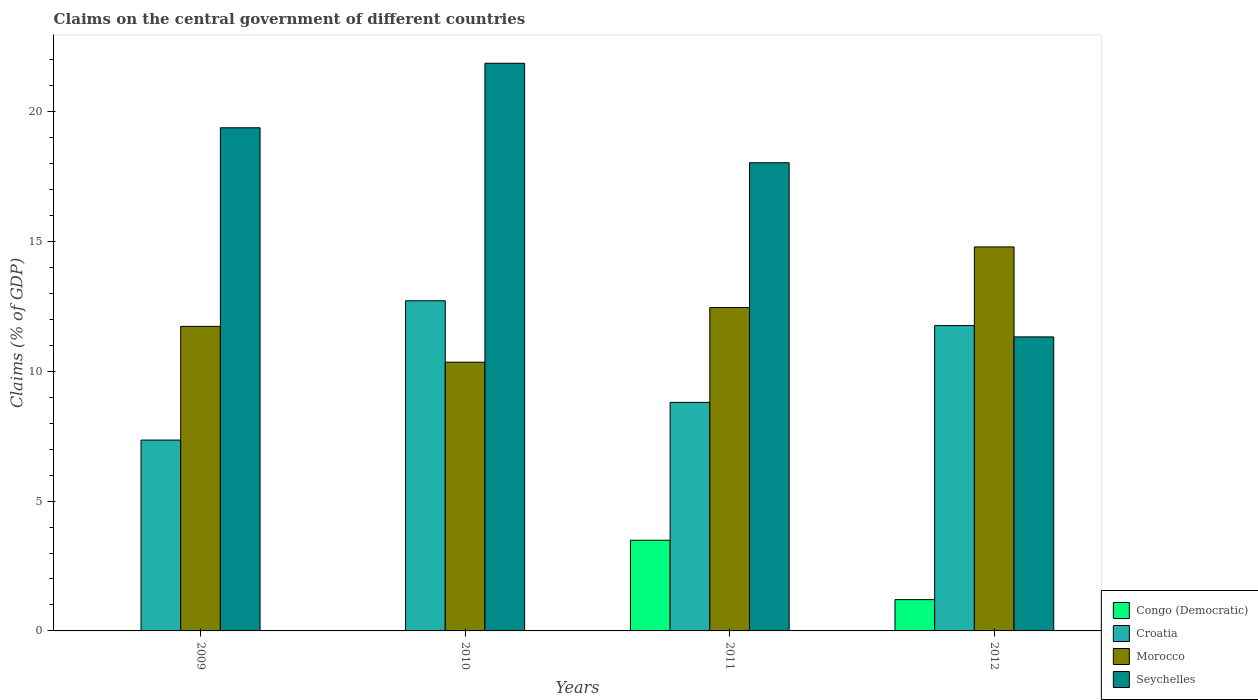Are the number of bars per tick equal to the number of legend labels?
Your response must be concise. No. Are the number of bars on each tick of the X-axis equal?
Your response must be concise. No. In how many cases, is the number of bars for a given year not equal to the number of legend labels?
Offer a very short reply. 2. What is the percentage of GDP claimed on the central government in Morocco in 2010?
Offer a terse response. 10.35. Across all years, what is the maximum percentage of GDP claimed on the central government in Seychelles?
Provide a succinct answer. 21.87. Across all years, what is the minimum percentage of GDP claimed on the central government in Morocco?
Ensure brevity in your answer.  10.35. What is the total percentage of GDP claimed on the central government in Morocco in the graph?
Offer a very short reply. 49.33. What is the difference between the percentage of GDP claimed on the central government in Seychelles in 2010 and that in 2012?
Your answer should be very brief. 10.54. What is the difference between the percentage of GDP claimed on the central government in Morocco in 2011 and the percentage of GDP claimed on the central government in Seychelles in 2010?
Keep it short and to the point. -9.41. What is the average percentage of GDP claimed on the central government in Morocco per year?
Your answer should be very brief. 12.33. In the year 2011, what is the difference between the percentage of GDP claimed on the central government in Morocco and percentage of GDP claimed on the central government in Congo (Democratic)?
Make the answer very short. 8.96. What is the ratio of the percentage of GDP claimed on the central government in Croatia in 2009 to that in 2010?
Ensure brevity in your answer.  0.58. Is the percentage of GDP claimed on the central government in Morocco in 2009 less than that in 2012?
Your response must be concise. Yes. Is the difference between the percentage of GDP claimed on the central government in Morocco in 2011 and 2012 greater than the difference between the percentage of GDP claimed on the central government in Congo (Democratic) in 2011 and 2012?
Provide a succinct answer. No. What is the difference between the highest and the second highest percentage of GDP claimed on the central government in Croatia?
Your response must be concise. 0.95. What is the difference between the highest and the lowest percentage of GDP claimed on the central government in Seychelles?
Keep it short and to the point. 10.54. In how many years, is the percentage of GDP claimed on the central government in Congo (Democratic) greater than the average percentage of GDP claimed on the central government in Congo (Democratic) taken over all years?
Provide a succinct answer. 2. Is the sum of the percentage of GDP claimed on the central government in Seychelles in 2009 and 2011 greater than the maximum percentage of GDP claimed on the central government in Morocco across all years?
Your answer should be compact. Yes. Is it the case that in every year, the sum of the percentage of GDP claimed on the central government in Congo (Democratic) and percentage of GDP claimed on the central government in Croatia is greater than the sum of percentage of GDP claimed on the central government in Morocco and percentage of GDP claimed on the central government in Seychelles?
Give a very brief answer. Yes. How many bars are there?
Keep it short and to the point. 14. Are all the bars in the graph horizontal?
Offer a very short reply. No. How many years are there in the graph?
Give a very brief answer. 4. Are the values on the major ticks of Y-axis written in scientific E-notation?
Make the answer very short. No. Does the graph contain any zero values?
Provide a succinct answer. Yes. Where does the legend appear in the graph?
Provide a succinct answer. Bottom right. What is the title of the graph?
Your answer should be compact. Claims on the central government of different countries. Does "Faeroe Islands" appear as one of the legend labels in the graph?
Your response must be concise. No. What is the label or title of the Y-axis?
Give a very brief answer. Claims (% of GDP). What is the Claims (% of GDP) in Congo (Democratic) in 2009?
Make the answer very short. 0. What is the Claims (% of GDP) in Croatia in 2009?
Offer a terse response. 7.35. What is the Claims (% of GDP) in Morocco in 2009?
Ensure brevity in your answer.  11.73. What is the Claims (% of GDP) of Seychelles in 2009?
Keep it short and to the point. 19.38. What is the Claims (% of GDP) of Congo (Democratic) in 2010?
Offer a terse response. 0. What is the Claims (% of GDP) of Croatia in 2010?
Ensure brevity in your answer.  12.72. What is the Claims (% of GDP) in Morocco in 2010?
Your response must be concise. 10.35. What is the Claims (% of GDP) of Seychelles in 2010?
Provide a short and direct response. 21.87. What is the Claims (% of GDP) of Congo (Democratic) in 2011?
Keep it short and to the point. 3.49. What is the Claims (% of GDP) in Croatia in 2011?
Your answer should be very brief. 8.8. What is the Claims (% of GDP) of Morocco in 2011?
Your answer should be very brief. 12.46. What is the Claims (% of GDP) of Seychelles in 2011?
Your answer should be very brief. 18.03. What is the Claims (% of GDP) in Congo (Democratic) in 2012?
Your answer should be very brief. 1.2. What is the Claims (% of GDP) of Croatia in 2012?
Provide a short and direct response. 11.76. What is the Claims (% of GDP) in Morocco in 2012?
Offer a very short reply. 14.79. What is the Claims (% of GDP) in Seychelles in 2012?
Provide a succinct answer. 11.33. Across all years, what is the maximum Claims (% of GDP) of Congo (Democratic)?
Your answer should be compact. 3.49. Across all years, what is the maximum Claims (% of GDP) in Croatia?
Provide a succinct answer. 12.72. Across all years, what is the maximum Claims (% of GDP) in Morocco?
Make the answer very short. 14.79. Across all years, what is the maximum Claims (% of GDP) of Seychelles?
Keep it short and to the point. 21.87. Across all years, what is the minimum Claims (% of GDP) in Croatia?
Provide a short and direct response. 7.35. Across all years, what is the minimum Claims (% of GDP) in Morocco?
Give a very brief answer. 10.35. Across all years, what is the minimum Claims (% of GDP) in Seychelles?
Offer a very short reply. 11.33. What is the total Claims (% of GDP) of Congo (Democratic) in the graph?
Your response must be concise. 4.7. What is the total Claims (% of GDP) of Croatia in the graph?
Offer a terse response. 40.63. What is the total Claims (% of GDP) of Morocco in the graph?
Provide a succinct answer. 49.33. What is the total Claims (% of GDP) of Seychelles in the graph?
Your answer should be very brief. 70.6. What is the difference between the Claims (% of GDP) in Croatia in 2009 and that in 2010?
Offer a very short reply. -5.37. What is the difference between the Claims (% of GDP) in Morocco in 2009 and that in 2010?
Make the answer very short. 1.38. What is the difference between the Claims (% of GDP) in Seychelles in 2009 and that in 2010?
Keep it short and to the point. -2.49. What is the difference between the Claims (% of GDP) of Croatia in 2009 and that in 2011?
Your response must be concise. -1.45. What is the difference between the Claims (% of GDP) of Morocco in 2009 and that in 2011?
Make the answer very short. -0.73. What is the difference between the Claims (% of GDP) in Seychelles in 2009 and that in 2011?
Make the answer very short. 1.35. What is the difference between the Claims (% of GDP) of Croatia in 2009 and that in 2012?
Offer a very short reply. -4.41. What is the difference between the Claims (% of GDP) of Morocco in 2009 and that in 2012?
Make the answer very short. -3.06. What is the difference between the Claims (% of GDP) in Seychelles in 2009 and that in 2012?
Provide a succinct answer. 8.06. What is the difference between the Claims (% of GDP) of Croatia in 2010 and that in 2011?
Your answer should be compact. 3.91. What is the difference between the Claims (% of GDP) in Morocco in 2010 and that in 2011?
Your answer should be very brief. -2.1. What is the difference between the Claims (% of GDP) of Seychelles in 2010 and that in 2011?
Your answer should be compact. 3.83. What is the difference between the Claims (% of GDP) of Croatia in 2010 and that in 2012?
Provide a succinct answer. 0.95. What is the difference between the Claims (% of GDP) in Morocco in 2010 and that in 2012?
Provide a short and direct response. -4.44. What is the difference between the Claims (% of GDP) in Seychelles in 2010 and that in 2012?
Keep it short and to the point. 10.54. What is the difference between the Claims (% of GDP) in Congo (Democratic) in 2011 and that in 2012?
Offer a terse response. 2.29. What is the difference between the Claims (% of GDP) of Croatia in 2011 and that in 2012?
Ensure brevity in your answer.  -2.96. What is the difference between the Claims (% of GDP) in Morocco in 2011 and that in 2012?
Offer a terse response. -2.33. What is the difference between the Claims (% of GDP) in Seychelles in 2011 and that in 2012?
Offer a very short reply. 6.71. What is the difference between the Claims (% of GDP) in Croatia in 2009 and the Claims (% of GDP) in Morocco in 2010?
Make the answer very short. -3. What is the difference between the Claims (% of GDP) of Croatia in 2009 and the Claims (% of GDP) of Seychelles in 2010?
Your answer should be compact. -14.51. What is the difference between the Claims (% of GDP) of Morocco in 2009 and the Claims (% of GDP) of Seychelles in 2010?
Offer a terse response. -10.14. What is the difference between the Claims (% of GDP) of Croatia in 2009 and the Claims (% of GDP) of Morocco in 2011?
Your answer should be very brief. -5.1. What is the difference between the Claims (% of GDP) of Croatia in 2009 and the Claims (% of GDP) of Seychelles in 2011?
Provide a short and direct response. -10.68. What is the difference between the Claims (% of GDP) of Morocco in 2009 and the Claims (% of GDP) of Seychelles in 2011?
Your response must be concise. -6.3. What is the difference between the Claims (% of GDP) of Croatia in 2009 and the Claims (% of GDP) of Morocco in 2012?
Offer a terse response. -7.44. What is the difference between the Claims (% of GDP) in Croatia in 2009 and the Claims (% of GDP) in Seychelles in 2012?
Give a very brief answer. -3.97. What is the difference between the Claims (% of GDP) in Morocco in 2009 and the Claims (% of GDP) in Seychelles in 2012?
Offer a very short reply. 0.4. What is the difference between the Claims (% of GDP) in Croatia in 2010 and the Claims (% of GDP) in Morocco in 2011?
Make the answer very short. 0.26. What is the difference between the Claims (% of GDP) in Croatia in 2010 and the Claims (% of GDP) in Seychelles in 2011?
Make the answer very short. -5.32. What is the difference between the Claims (% of GDP) of Morocco in 2010 and the Claims (% of GDP) of Seychelles in 2011?
Make the answer very short. -7.68. What is the difference between the Claims (% of GDP) in Croatia in 2010 and the Claims (% of GDP) in Morocco in 2012?
Keep it short and to the point. -2.07. What is the difference between the Claims (% of GDP) in Croatia in 2010 and the Claims (% of GDP) in Seychelles in 2012?
Provide a succinct answer. 1.39. What is the difference between the Claims (% of GDP) of Morocco in 2010 and the Claims (% of GDP) of Seychelles in 2012?
Your response must be concise. -0.97. What is the difference between the Claims (% of GDP) of Congo (Democratic) in 2011 and the Claims (% of GDP) of Croatia in 2012?
Your answer should be very brief. -8.27. What is the difference between the Claims (% of GDP) in Congo (Democratic) in 2011 and the Claims (% of GDP) in Morocco in 2012?
Make the answer very short. -11.3. What is the difference between the Claims (% of GDP) of Congo (Democratic) in 2011 and the Claims (% of GDP) of Seychelles in 2012?
Offer a very short reply. -7.83. What is the difference between the Claims (% of GDP) in Croatia in 2011 and the Claims (% of GDP) in Morocco in 2012?
Your answer should be compact. -5.99. What is the difference between the Claims (% of GDP) in Croatia in 2011 and the Claims (% of GDP) in Seychelles in 2012?
Keep it short and to the point. -2.52. What is the difference between the Claims (% of GDP) in Morocco in 2011 and the Claims (% of GDP) in Seychelles in 2012?
Give a very brief answer. 1.13. What is the average Claims (% of GDP) in Congo (Democratic) per year?
Your answer should be very brief. 1.17. What is the average Claims (% of GDP) in Croatia per year?
Provide a short and direct response. 10.16. What is the average Claims (% of GDP) in Morocco per year?
Your response must be concise. 12.33. What is the average Claims (% of GDP) of Seychelles per year?
Keep it short and to the point. 17.65. In the year 2009, what is the difference between the Claims (% of GDP) in Croatia and Claims (% of GDP) in Morocco?
Ensure brevity in your answer.  -4.38. In the year 2009, what is the difference between the Claims (% of GDP) of Croatia and Claims (% of GDP) of Seychelles?
Offer a very short reply. -12.03. In the year 2009, what is the difference between the Claims (% of GDP) in Morocco and Claims (% of GDP) in Seychelles?
Provide a succinct answer. -7.65. In the year 2010, what is the difference between the Claims (% of GDP) of Croatia and Claims (% of GDP) of Morocco?
Your response must be concise. 2.37. In the year 2010, what is the difference between the Claims (% of GDP) of Croatia and Claims (% of GDP) of Seychelles?
Offer a very short reply. -9.15. In the year 2010, what is the difference between the Claims (% of GDP) in Morocco and Claims (% of GDP) in Seychelles?
Provide a short and direct response. -11.51. In the year 2011, what is the difference between the Claims (% of GDP) in Congo (Democratic) and Claims (% of GDP) in Croatia?
Provide a succinct answer. -5.31. In the year 2011, what is the difference between the Claims (% of GDP) of Congo (Democratic) and Claims (% of GDP) of Morocco?
Your response must be concise. -8.96. In the year 2011, what is the difference between the Claims (% of GDP) of Congo (Democratic) and Claims (% of GDP) of Seychelles?
Offer a very short reply. -14.54. In the year 2011, what is the difference between the Claims (% of GDP) of Croatia and Claims (% of GDP) of Morocco?
Offer a terse response. -3.65. In the year 2011, what is the difference between the Claims (% of GDP) of Croatia and Claims (% of GDP) of Seychelles?
Provide a succinct answer. -9.23. In the year 2011, what is the difference between the Claims (% of GDP) of Morocco and Claims (% of GDP) of Seychelles?
Ensure brevity in your answer.  -5.58. In the year 2012, what is the difference between the Claims (% of GDP) of Congo (Democratic) and Claims (% of GDP) of Croatia?
Your answer should be very brief. -10.56. In the year 2012, what is the difference between the Claims (% of GDP) in Congo (Democratic) and Claims (% of GDP) in Morocco?
Offer a terse response. -13.59. In the year 2012, what is the difference between the Claims (% of GDP) in Congo (Democratic) and Claims (% of GDP) in Seychelles?
Offer a terse response. -10.12. In the year 2012, what is the difference between the Claims (% of GDP) in Croatia and Claims (% of GDP) in Morocco?
Give a very brief answer. -3.03. In the year 2012, what is the difference between the Claims (% of GDP) of Croatia and Claims (% of GDP) of Seychelles?
Keep it short and to the point. 0.44. In the year 2012, what is the difference between the Claims (% of GDP) of Morocco and Claims (% of GDP) of Seychelles?
Your answer should be very brief. 3.46. What is the ratio of the Claims (% of GDP) of Croatia in 2009 to that in 2010?
Ensure brevity in your answer.  0.58. What is the ratio of the Claims (% of GDP) in Morocco in 2009 to that in 2010?
Provide a succinct answer. 1.13. What is the ratio of the Claims (% of GDP) of Seychelles in 2009 to that in 2010?
Offer a terse response. 0.89. What is the ratio of the Claims (% of GDP) in Croatia in 2009 to that in 2011?
Ensure brevity in your answer.  0.83. What is the ratio of the Claims (% of GDP) of Morocco in 2009 to that in 2011?
Make the answer very short. 0.94. What is the ratio of the Claims (% of GDP) of Seychelles in 2009 to that in 2011?
Make the answer very short. 1.07. What is the ratio of the Claims (% of GDP) in Morocco in 2009 to that in 2012?
Your answer should be very brief. 0.79. What is the ratio of the Claims (% of GDP) of Seychelles in 2009 to that in 2012?
Make the answer very short. 1.71. What is the ratio of the Claims (% of GDP) in Croatia in 2010 to that in 2011?
Ensure brevity in your answer.  1.44. What is the ratio of the Claims (% of GDP) in Morocco in 2010 to that in 2011?
Provide a short and direct response. 0.83. What is the ratio of the Claims (% of GDP) of Seychelles in 2010 to that in 2011?
Your response must be concise. 1.21. What is the ratio of the Claims (% of GDP) in Croatia in 2010 to that in 2012?
Your response must be concise. 1.08. What is the ratio of the Claims (% of GDP) in Morocco in 2010 to that in 2012?
Make the answer very short. 0.7. What is the ratio of the Claims (% of GDP) in Seychelles in 2010 to that in 2012?
Provide a short and direct response. 1.93. What is the ratio of the Claims (% of GDP) in Congo (Democratic) in 2011 to that in 2012?
Your response must be concise. 2.9. What is the ratio of the Claims (% of GDP) of Croatia in 2011 to that in 2012?
Keep it short and to the point. 0.75. What is the ratio of the Claims (% of GDP) of Morocco in 2011 to that in 2012?
Ensure brevity in your answer.  0.84. What is the ratio of the Claims (% of GDP) of Seychelles in 2011 to that in 2012?
Give a very brief answer. 1.59. What is the difference between the highest and the second highest Claims (% of GDP) of Croatia?
Provide a short and direct response. 0.95. What is the difference between the highest and the second highest Claims (% of GDP) in Morocco?
Provide a succinct answer. 2.33. What is the difference between the highest and the second highest Claims (% of GDP) in Seychelles?
Your answer should be compact. 2.49. What is the difference between the highest and the lowest Claims (% of GDP) in Congo (Democratic)?
Offer a terse response. 3.49. What is the difference between the highest and the lowest Claims (% of GDP) in Croatia?
Your answer should be compact. 5.37. What is the difference between the highest and the lowest Claims (% of GDP) in Morocco?
Keep it short and to the point. 4.44. What is the difference between the highest and the lowest Claims (% of GDP) of Seychelles?
Offer a very short reply. 10.54. 